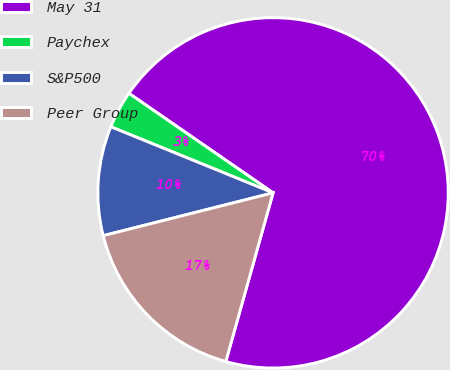<chart> <loc_0><loc_0><loc_500><loc_500><pie_chart><fcel>May 31<fcel>Paychex<fcel>S&P500<fcel>Peer Group<nl><fcel>69.73%<fcel>3.46%<fcel>10.09%<fcel>16.72%<nl></chart> 